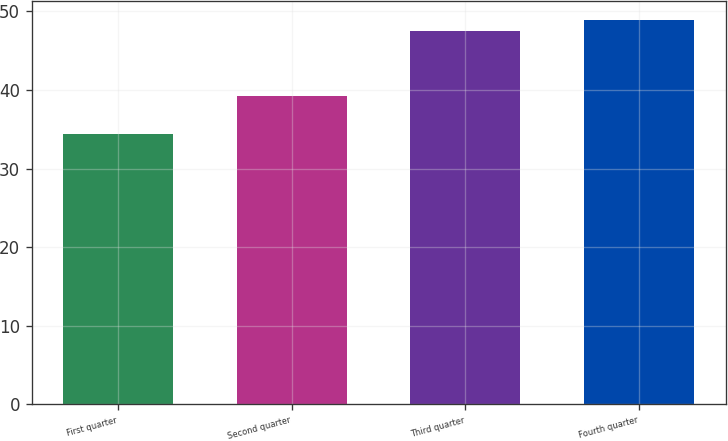Convert chart. <chart><loc_0><loc_0><loc_500><loc_500><bar_chart><fcel>First quarter<fcel>Second quarter<fcel>Third quarter<fcel>Fourth quarter<nl><fcel>34.35<fcel>39.22<fcel>47.52<fcel>48.86<nl></chart> 